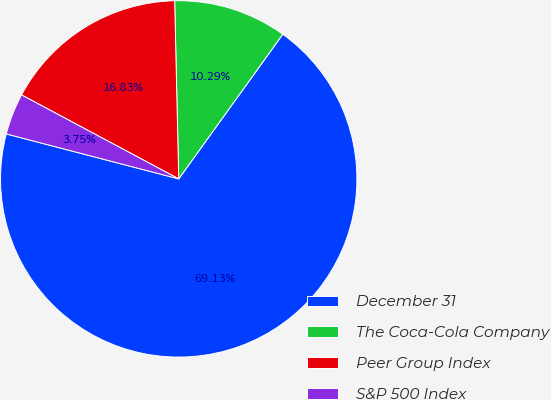Convert chart. <chart><loc_0><loc_0><loc_500><loc_500><pie_chart><fcel>December 31<fcel>The Coca-Cola Company<fcel>Peer Group Index<fcel>S&P 500 Index<nl><fcel>69.14%<fcel>10.29%<fcel>16.83%<fcel>3.75%<nl></chart> 